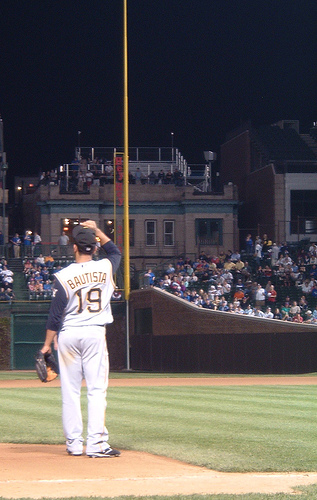Could you explain the mood and atmosphere created by the lighting and setting in this image? The image exudes an intense yet contemplative ambiance. The bright lights of the stadium cast stark shadows and illuminate the player, creating a focal point against the darker, muted crowd. This lighting accentuates the seriousness of the game moment, adding a dramatic flair to the scene, which evokes feelings of anticipation and excitement. 